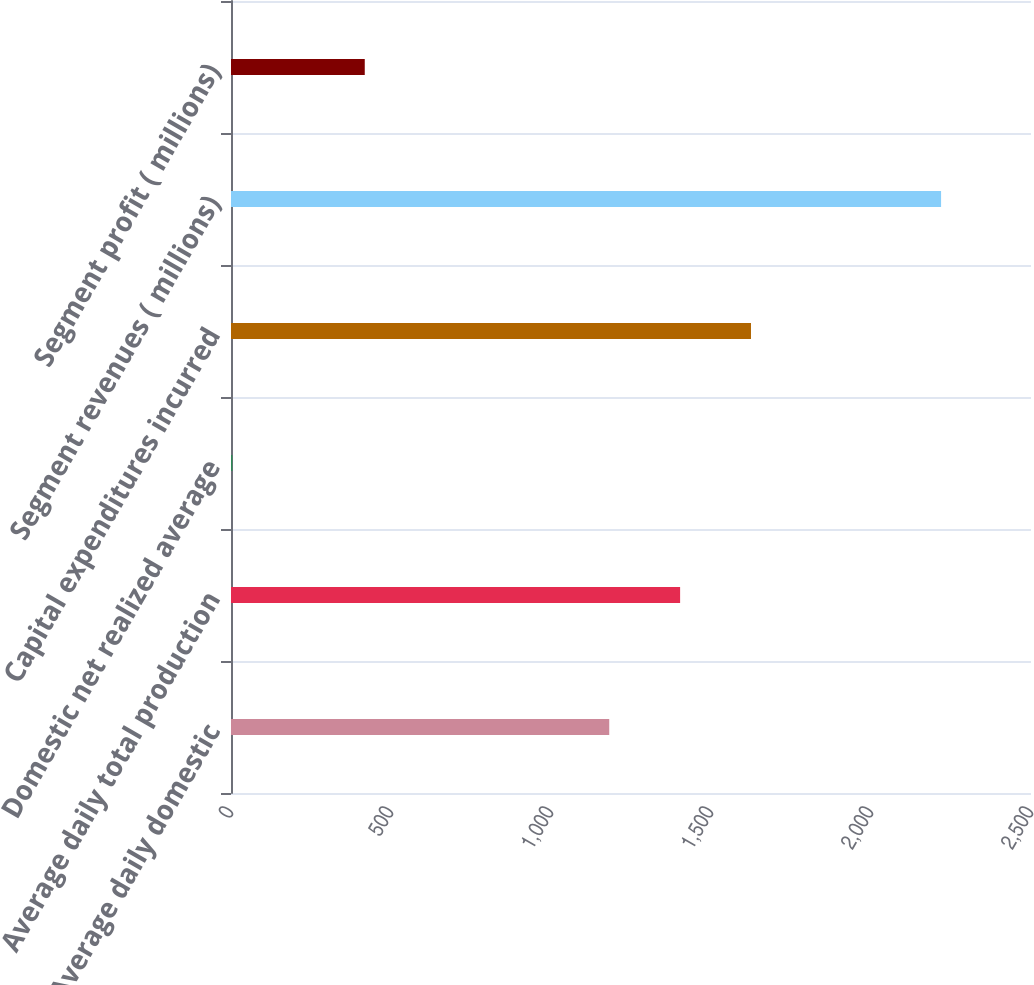<chart> <loc_0><loc_0><loc_500><loc_500><bar_chart><fcel>Average daily domestic<fcel>Average daily total production<fcel>Domestic net realized average<fcel>Capital expenditures incurred<fcel>Segment revenues ( millions)<fcel>Segment profit ( millions)<nl><fcel>1182<fcel>1403.48<fcel>4.22<fcel>1624.96<fcel>2219<fcel>418<nl></chart> 